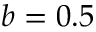Convert formula to latex. <formula><loc_0><loc_0><loc_500><loc_500>b = 0 . 5</formula> 